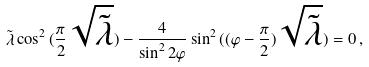Convert formula to latex. <formula><loc_0><loc_0><loc_500><loc_500>\tilde { \lambda } \cos ^ { 2 } { ( \frac { \pi } { 2 } \sqrt { \tilde { \lambda } } ) } - \frac { 4 } { \sin ^ { 2 } { 2 \varphi } } \sin ^ { 2 } { ( ( \varphi - \frac { \pi } { 2 } ) \sqrt { \tilde { \lambda } } ) } = 0 \, ,</formula> 